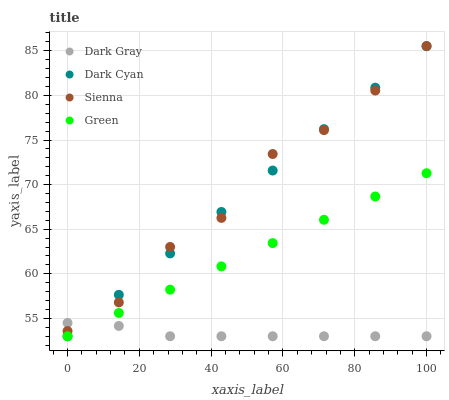Does Dark Gray have the minimum area under the curve?
Answer yes or no. Yes. Does Sienna have the maximum area under the curve?
Answer yes or no. Yes. Does Dark Cyan have the minimum area under the curve?
Answer yes or no. No. Does Dark Cyan have the maximum area under the curve?
Answer yes or no. No. Is Dark Cyan the smoothest?
Answer yes or no. Yes. Is Sienna the roughest?
Answer yes or no. Yes. Is Green the smoothest?
Answer yes or no. No. Is Green the roughest?
Answer yes or no. No. Does Dark Gray have the lowest value?
Answer yes or no. Yes. Does Sienna have the lowest value?
Answer yes or no. No. Does Sienna have the highest value?
Answer yes or no. Yes. Does Dark Cyan have the highest value?
Answer yes or no. No. Is Green less than Sienna?
Answer yes or no. Yes. Is Sienna greater than Green?
Answer yes or no. Yes. Does Green intersect Dark Cyan?
Answer yes or no. Yes. Is Green less than Dark Cyan?
Answer yes or no. No. Is Green greater than Dark Cyan?
Answer yes or no. No. Does Green intersect Sienna?
Answer yes or no. No. 